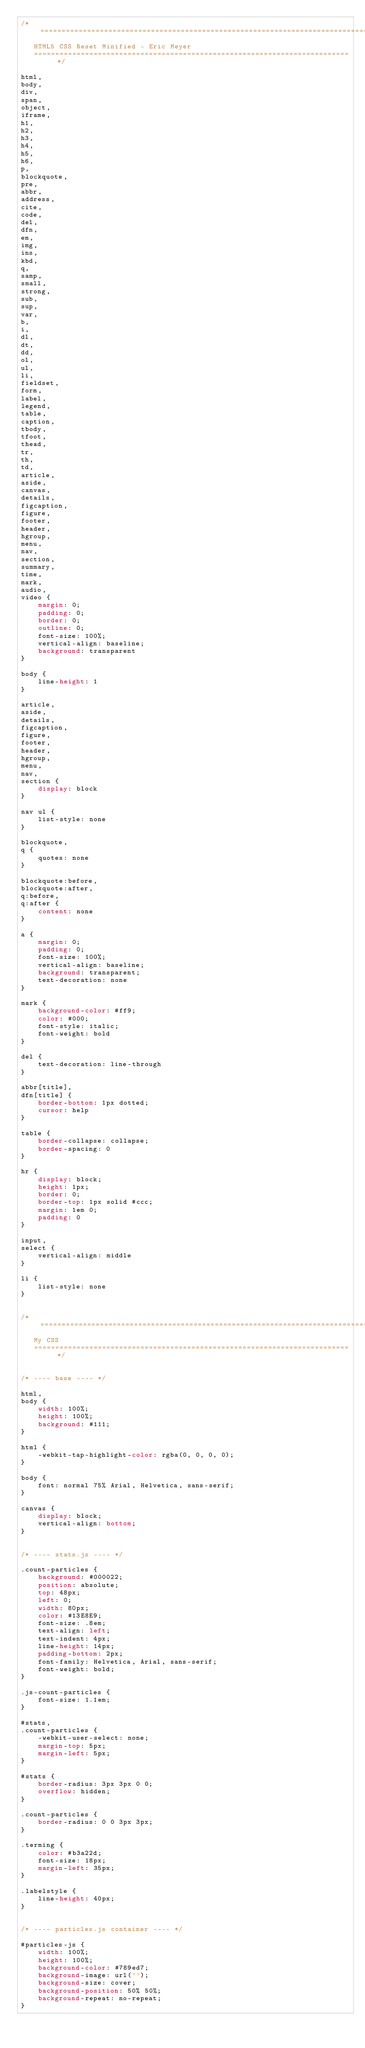<code> <loc_0><loc_0><loc_500><loc_500><_CSS_>/* =============================================================================
   HTML5 CSS Reset Minified - Eric Meyer
   ========================================================================== */

html,
body,
div,
span,
object,
iframe,
h1,
h2,
h3,
h4,
h5,
h6,
p,
blockquote,
pre,
abbr,
address,
cite,
code,
del,
dfn,
em,
img,
ins,
kbd,
q,
samp,
small,
strong,
sub,
sup,
var,
b,
i,
dl,
dt,
dd,
ol,
ul,
li,
fieldset,
form,
label,
legend,
table,
caption,
tbody,
tfoot,
thead,
tr,
th,
td,
article,
aside,
canvas,
details,
figcaption,
figure,
footer,
header,
hgroup,
menu,
nav,
section,
summary,
time,
mark,
audio,
video {
    margin: 0;
    padding: 0;
    border: 0;
    outline: 0;
    font-size: 100%;
    vertical-align: baseline;
    background: transparent
}

body {
    line-height: 1
}

article,
aside,
details,
figcaption,
figure,
footer,
header,
hgroup,
menu,
nav,
section {
    display: block
}

nav ul {
    list-style: none
}

blockquote,
q {
    quotes: none
}

blockquote:before,
blockquote:after,
q:before,
q:after {
    content: none
}

a {
    margin: 0;
    padding: 0;
    font-size: 100%;
    vertical-align: baseline;
    background: transparent;
    text-decoration: none
}

mark {
    background-color: #ff9;
    color: #000;
    font-style: italic;
    font-weight: bold
}

del {
    text-decoration: line-through
}

abbr[title],
dfn[title] {
    border-bottom: 1px dotted;
    cursor: help
}

table {
    border-collapse: collapse;
    border-spacing: 0
}

hr {
    display: block;
    height: 1px;
    border: 0;
    border-top: 1px solid #ccc;
    margin: 1em 0;
    padding: 0
}

input,
select {
    vertical-align: middle
}

li {
    list-style: none
}


/* =============================================================================
   My CSS
   ========================================================================== */


/* ---- base ---- */

html,
body {
    width: 100%;
    height: 100%;
    background: #111;
}

html {
    -webkit-tap-highlight-color: rgba(0, 0, 0, 0);
}

body {
    font: normal 75% Arial, Helvetica, sans-serif;
}

canvas {
    display: block;
    vertical-align: bottom;
}


/* ---- stats.js ---- */

.count-particles {
    background: #000022;
    position: absolute;
    top: 48px;
    left: 0;
    width: 80px;
    color: #13E8E9;
    font-size: .8em;
    text-align: left;
    text-indent: 4px;
    line-height: 14px;
    padding-bottom: 2px;
    font-family: Helvetica, Arial, sans-serif;
    font-weight: bold;
}

.js-count-particles {
    font-size: 1.1em;
}

#stats,
.count-particles {
    -webkit-user-select: none;
    margin-top: 5px;
    margin-left: 5px;
}

#stats {
    border-radius: 3px 3px 0 0;
    overflow: hidden;
}

.count-particles {
    border-radius: 0 0 3px 3px;
}

.terming {
    color: #b3a22d;
    font-size: 18px;
    margin-left: 35px;
}

.labelstyle {
    line-height: 40px;
}


/* ---- particles.js container ---- */

#particles-js {
    width: 100%;
    height: 100%;
    background-color: #789ed7;
    background-image: url('');
    background-size: cover;
    background-position: 50% 50%;
    background-repeat: no-repeat;
}</code> 